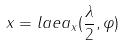<formula> <loc_0><loc_0><loc_500><loc_500>x = l a e a _ { x } ( \frac { \lambda } { 2 } , \varphi )</formula> 